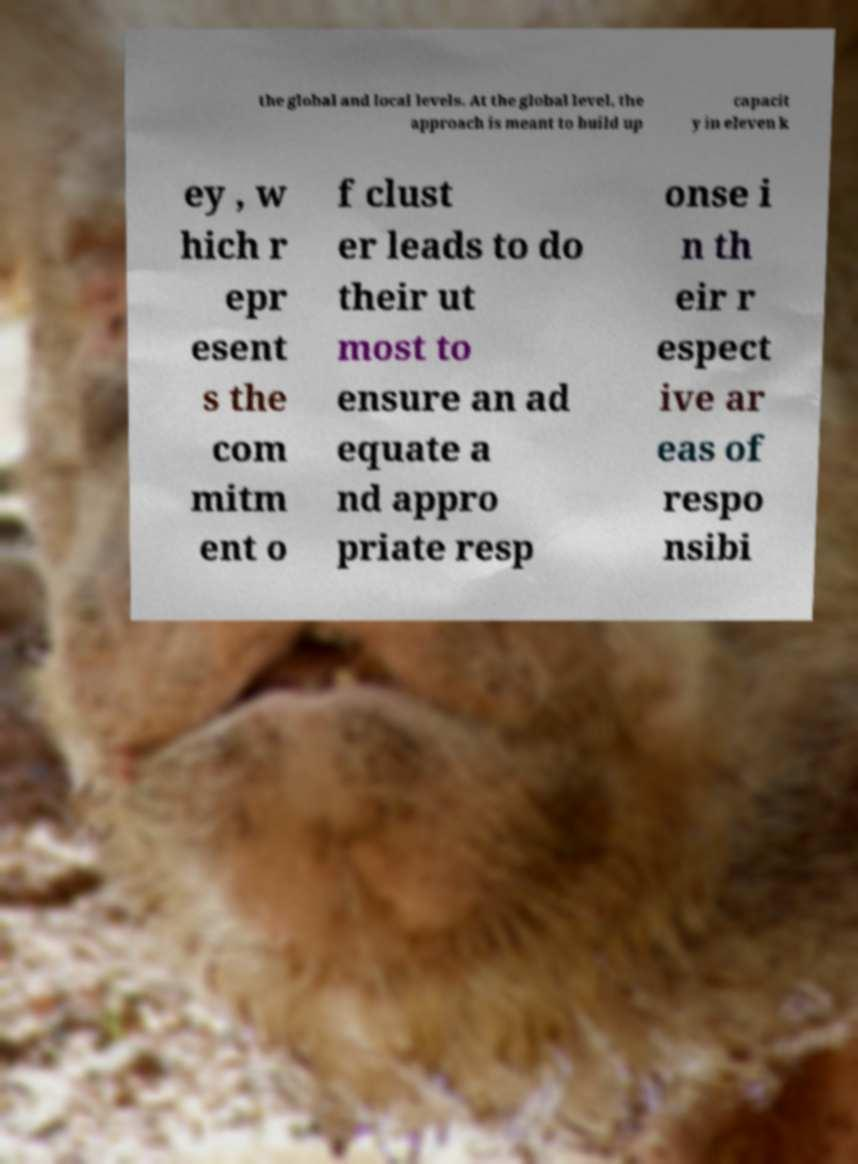Please read and relay the text visible in this image. What does it say? the global and local levels. At the global level, the approach is meant to build up capacit y in eleven k ey , w hich r epr esent s the com mitm ent o f clust er leads to do their ut most to ensure an ad equate a nd appro priate resp onse i n th eir r espect ive ar eas of respo nsibi 